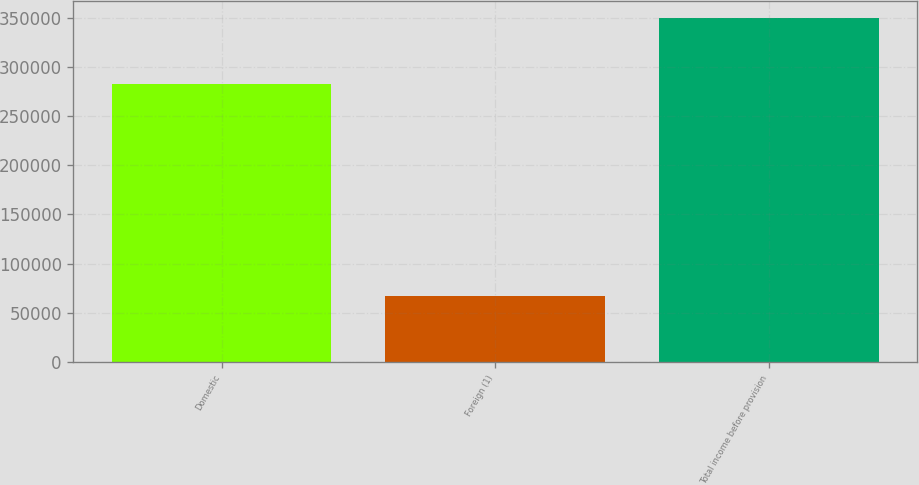Convert chart to OTSL. <chart><loc_0><loc_0><loc_500><loc_500><bar_chart><fcel>Domestic<fcel>Foreign (1)<fcel>Total income before provision<nl><fcel>282764<fcel>66790<fcel>349554<nl></chart> 